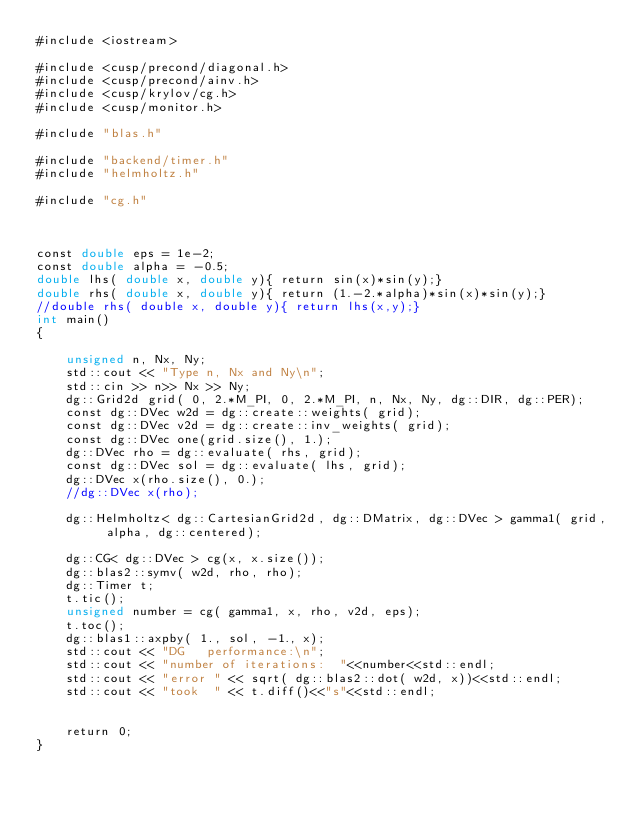<code> <loc_0><loc_0><loc_500><loc_500><_Cuda_>#include <iostream>

#include <cusp/precond/diagonal.h>
#include <cusp/precond/ainv.h>
#include <cusp/krylov/cg.h>
#include <cusp/monitor.h>

#include "blas.h"

#include "backend/timer.h"
#include "helmholtz.h"

#include "cg.h"



const double eps = 1e-2;
const double alpha = -0.5;
double lhs( double x, double y){ return sin(x)*sin(y);}
double rhs( double x, double y){ return (1.-2.*alpha)*sin(x)*sin(y);}
//double rhs( double x, double y){ return lhs(x,y);}
int main()
{

    unsigned n, Nx, Ny;
    std::cout << "Type n, Nx and Ny\n";
    std::cin >> n>> Nx >> Ny;
    dg::Grid2d grid( 0, 2.*M_PI, 0, 2.*M_PI, n, Nx, Ny, dg::DIR, dg::PER);
    const dg::DVec w2d = dg::create::weights( grid);
    const dg::DVec v2d = dg::create::inv_weights( grid);
    const dg::DVec one(grid.size(), 1.);
    dg::DVec rho = dg::evaluate( rhs, grid);
    const dg::DVec sol = dg::evaluate( lhs, grid);
    dg::DVec x(rho.size(), 0.);
    //dg::DVec x(rho);

    dg::Helmholtz< dg::CartesianGrid2d, dg::DMatrix, dg::DVec > gamma1( grid, alpha, dg::centered);

    dg::CG< dg::DVec > cg(x, x.size());
    dg::blas2::symv( w2d, rho, rho);
    dg::Timer t;
    t.tic();
    unsigned number = cg( gamma1, x, rho, v2d, eps);
    t.toc();
    dg::blas1::axpby( 1., sol, -1., x);
    std::cout << "DG   performance:\n";
    std::cout << "number of iterations:  "<<number<<std::endl;
    std::cout << "error " << sqrt( dg::blas2::dot( w2d, x))<<std::endl;
    std::cout << "took  " << t.diff()<<"s"<<std::endl;


    return 0;
}



</code> 